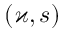<formula> <loc_0><loc_0><loc_500><loc_500>( \varkappa , s )</formula> 